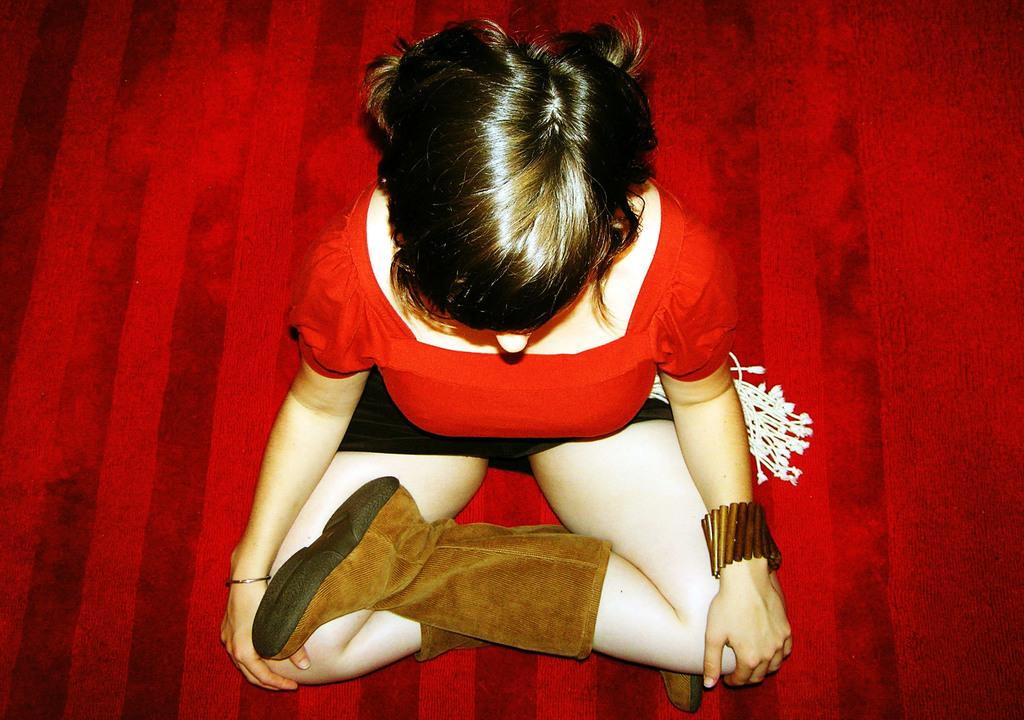Who is the main subject in the image? There is a woman in the image. What is the woman wearing? The woman is wearing a red dress and long boots. What is the woman sitting on? The woman is sitting on a red color surface. What type of substance is the woman applying to her wound in the image? There is no wound or substance present in the image; the woman is simply sitting on a red surface. 